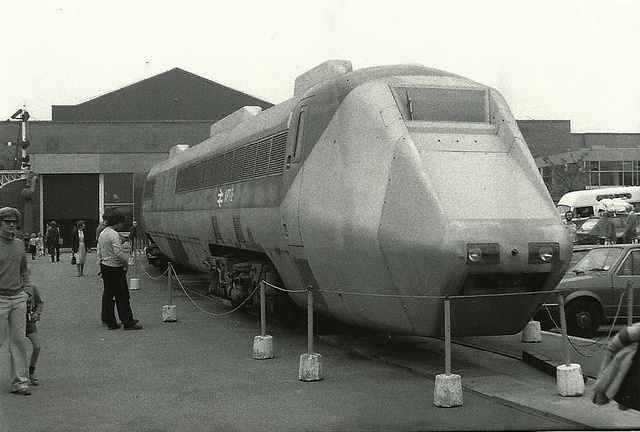Describe the objects in this image and their specific colors. I can see train in ivory, gray, darkgray, black, and lightgray tones, car in ivory, black, gray, darkgray, and lightgray tones, people in ivory, gray, and black tones, people in ivory, black, gray, and darkgray tones, and car in ivory, gray, black, darkgray, and lightgray tones in this image. 